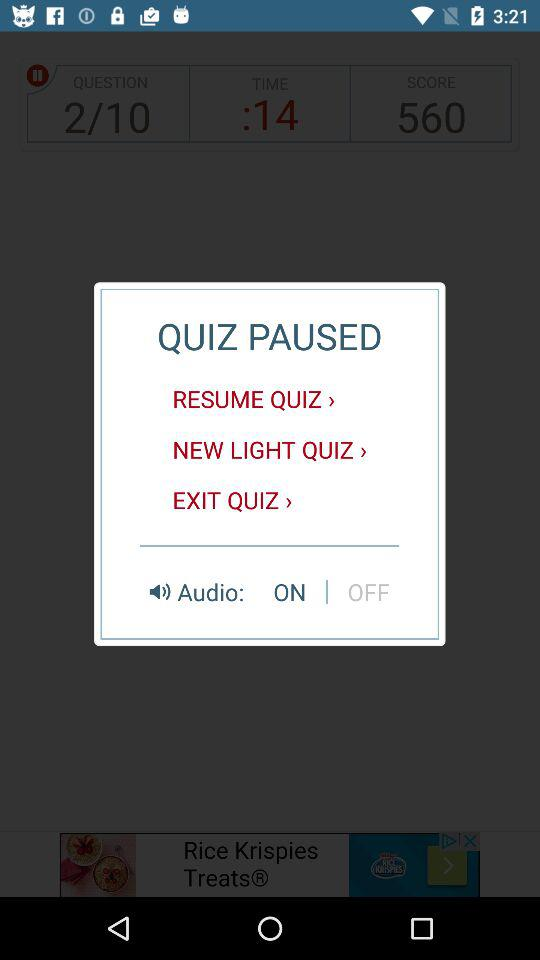What options are available under "QUIZ PAUSED"? The available options are "RESUME QUIZ ", "NEW LIGHT QUIZ" and "EXIT QUIZ ". 